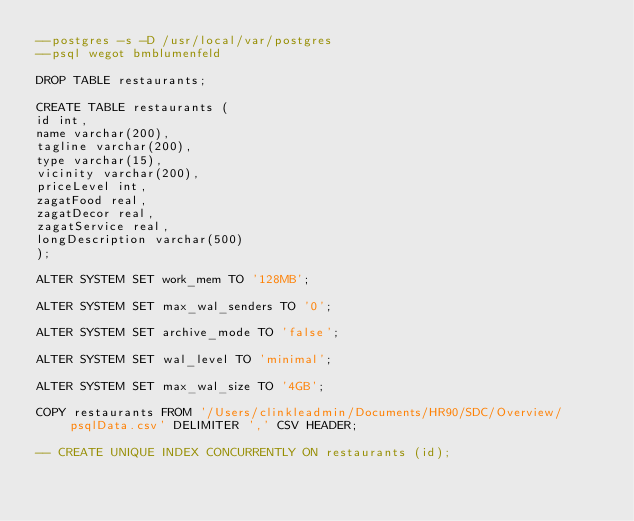Convert code to text. <code><loc_0><loc_0><loc_500><loc_500><_SQL_>--postgres -s -D /usr/local/var/postgres
--psql wegot bmblumenfeld

DROP TABLE restaurants;

CREATE TABLE restaurants (                                                               
id int,
name varchar(200),
tagline varchar(200),
type varchar(15),
vicinity varchar(200),
priceLevel int,
zagatFood real,
zagatDecor real,
zagatService real,
longDescription varchar(500)
);

ALTER SYSTEM SET work_mem TO '128MB';

ALTER SYSTEM SET max_wal_senders TO '0';

ALTER SYSTEM SET archive_mode TO 'false';

ALTER SYSTEM SET wal_level TO 'minimal';

ALTER SYSTEM SET max_wal_size TO '4GB';

COPY restaurants FROM '/Users/clinkleadmin/Documents/HR90/SDC/Overview/psqlData.csv' DELIMITER ',' CSV HEADER;

-- CREATE UNIQUE INDEX CONCURRENTLY ON restaurants (id);
</code> 